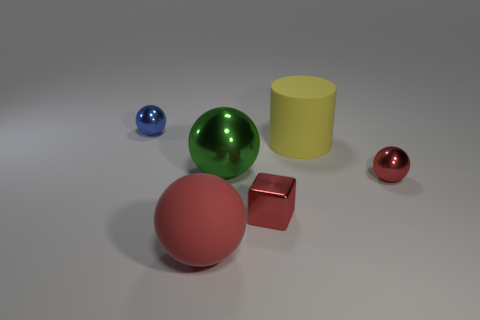Subtract all blue blocks. Subtract all green spheres. How many blocks are left? 1 Add 1 large gray matte things. How many objects exist? 7 Subtract all spheres. How many objects are left? 2 Subtract all red shiny cubes. Subtract all green metallic objects. How many objects are left? 4 Add 1 big red rubber objects. How many big red rubber objects are left? 2 Add 1 large objects. How many large objects exist? 4 Subtract 0 brown blocks. How many objects are left? 6 